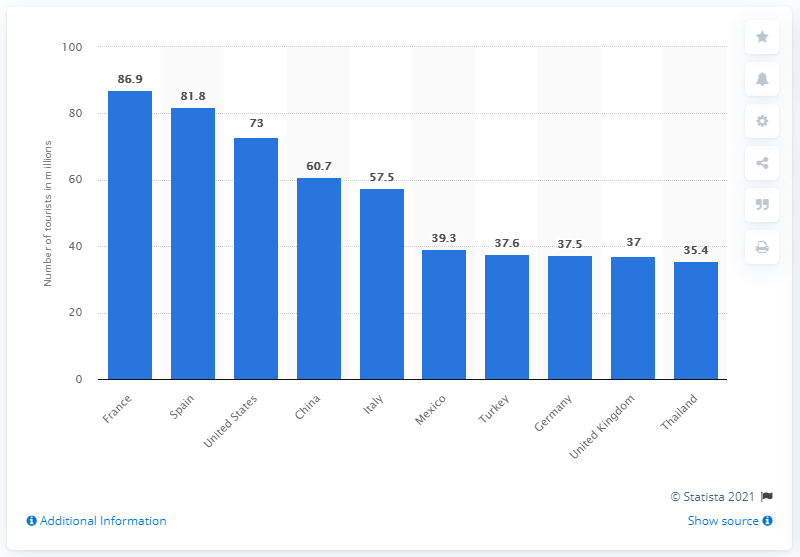Indicate a few pertinent items in this graphic. In 2017, France was the most popular destination for foreign tourists. In 2017, France welcomed a total of 81.8 million visitors. 